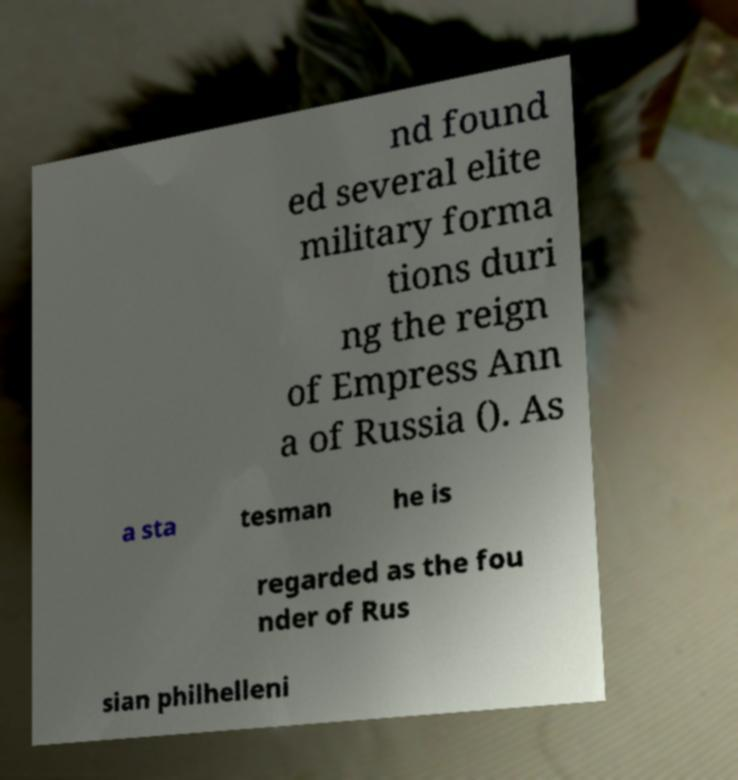For documentation purposes, I need the text within this image transcribed. Could you provide that? nd found ed several elite military forma tions duri ng the reign of Empress Ann a of Russia (). As a sta tesman he is regarded as the fou nder of Rus sian philhelleni 